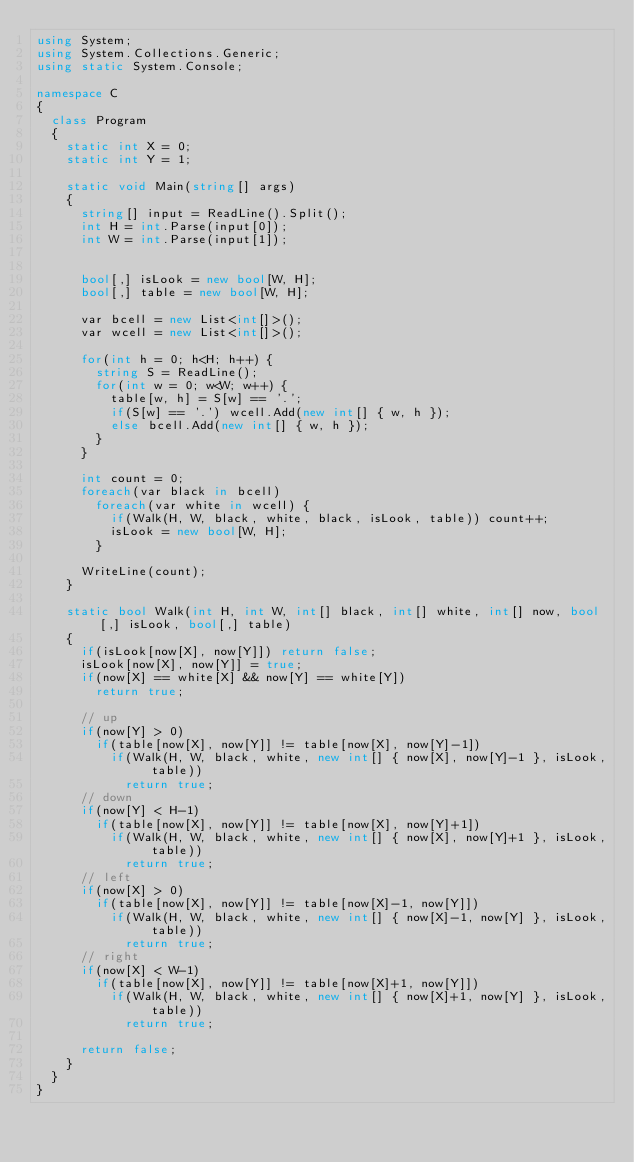Convert code to text. <code><loc_0><loc_0><loc_500><loc_500><_C#_>using System;
using System.Collections.Generic;
using static System.Console;

namespace C
{
  class Program
  {
    static int X = 0;
    static int Y = 1;

    static void Main(string[] args)
    {
      string[] input = ReadLine().Split();
      int H = int.Parse(input[0]);
      int W = int.Parse(input[1]);


      bool[,] isLook = new bool[W, H];
      bool[,] table = new bool[W, H];

      var bcell = new List<int[]>();
      var wcell = new List<int[]>();

      for(int h = 0; h<H; h++) {
        string S = ReadLine();
        for(int w = 0; w<W; w++) {
          table[w, h] = S[w] == '.';
          if(S[w] == '.') wcell.Add(new int[] { w, h });
          else bcell.Add(new int[] { w, h });
        }
      }

      int count = 0;
      foreach(var black in bcell)
        foreach(var white in wcell) {
          if(Walk(H, W, black, white, black, isLook, table)) count++;
          isLook = new bool[W, H];
        }

      WriteLine(count);
    }

    static bool Walk(int H, int W, int[] black, int[] white, int[] now, bool[,] isLook, bool[,] table)
    {
      if(isLook[now[X], now[Y]]) return false;
      isLook[now[X], now[Y]] = true;
      if(now[X] == white[X] && now[Y] == white[Y])
        return true;
      
      // up
      if(now[Y] > 0)
        if(table[now[X], now[Y]] != table[now[X], now[Y]-1])
          if(Walk(H, W, black, white, new int[] { now[X], now[Y]-1 }, isLook, table))
            return true;
      // down
      if(now[Y] < H-1)
        if(table[now[X], now[Y]] != table[now[X], now[Y]+1])
          if(Walk(H, W, black, white, new int[] { now[X], now[Y]+1 }, isLook, table))
            return true;
      // left
      if(now[X] > 0)
        if(table[now[X], now[Y]] != table[now[X]-1, now[Y]])
          if(Walk(H, W, black, white, new int[] { now[X]-1, now[Y] }, isLook, table))
            return true;
      // right
      if(now[X] < W-1)
        if(table[now[X], now[Y]] != table[now[X]+1, now[Y]])
          if(Walk(H, W, black, white, new int[] { now[X]+1, now[Y] }, isLook, table))
            return true;

      return false;
    }
  }
}
</code> 